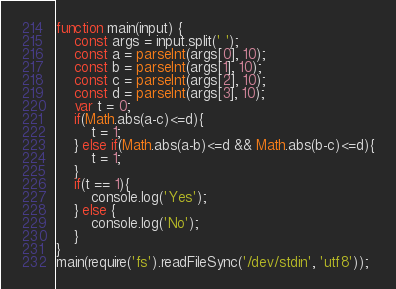<code> <loc_0><loc_0><loc_500><loc_500><_JavaScript_>function main(input) {
	const args = input.split(' ');
	const a = parseInt(args[0], 10);
	const b = parseInt(args[1], 10);
	const c = parseInt(args[2], 10);
	const d = parseInt(args[3], 10);
	var t = 0;
	if(Math.abs(a-c)<=d){
		t = 1;
	} else if(Math.abs(a-b)<=d && Math.abs(b-c)<=d){
		t = 1;
	}
	if(t == 1){
		console.log('Yes');
	} else {
		console.log('No');
	}
}
main(require('fs').readFileSync('/dev/stdin', 'utf8'));</code> 